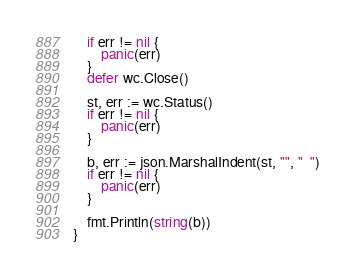<code> <loc_0><loc_0><loc_500><loc_500><_Go_>	if err != nil {
		panic(err)
	}
	defer wc.Close()

	st, err := wc.Status()
	if err != nil {
		panic(err)
	}

	b, err := json.MarshalIndent(st, "", "  ")
	if err != nil {
		panic(err)
	}

	fmt.Println(string(b))
}
</code> 